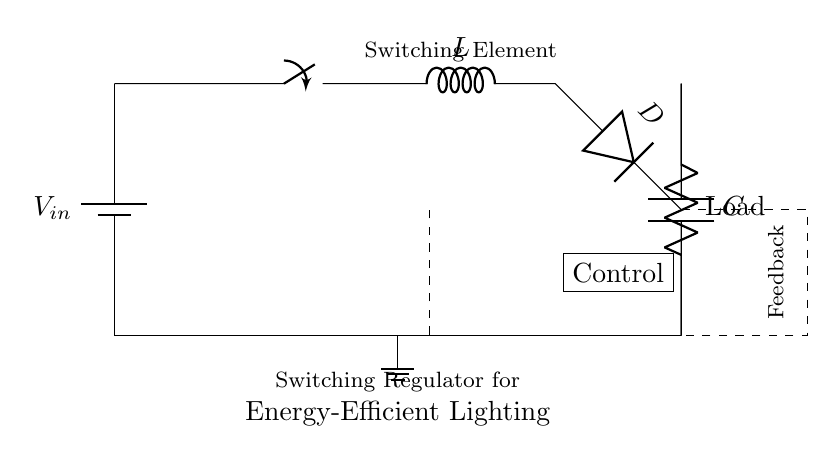What is the power supply used in this circuit? The circuit is powered by a battery, indicated by the symbol labeled V_in at the input.
Answer: battery What component is used to store energy in the circuit? An inductor, represented by the component label L, stores energy when the switch is closed.
Answer: L What is the purpose of the diode in the circuit? The diode, labeled D, allows current to flow in one direction and prevents backflow when the switch opens, ensuring the load receives power.
Answer: prevent backflow How does the voltage across the load compare to the input voltage? The circuit is a switching regulator, and it converts input voltage V_in to a regulated output voltage that can be lower than V_in, depending on the duty cycle of the switch.
Answer: regulated What is the function of the control block in the circuit? The control block, illustrated by the dashed box, manages the switch operation to maintain the desired output voltage, ensuring efficient energy use.
Answer: manage switching What is the significance of the feedback line in this configuration? The feedback line, indicated by the dashed lines connecting the load to the control block, helps in regulating the output voltage by comparing it to a reference voltage and adjusting the switch accordingly.
Answer: regulation How does this circuit improve energy efficiency in lighting systems? This switching regulator design minimizes energy wasted as heat and improves efficiency by rapidly switching the power on and off, providing only the needed amount of power to the load.
Answer: energy-efficient 